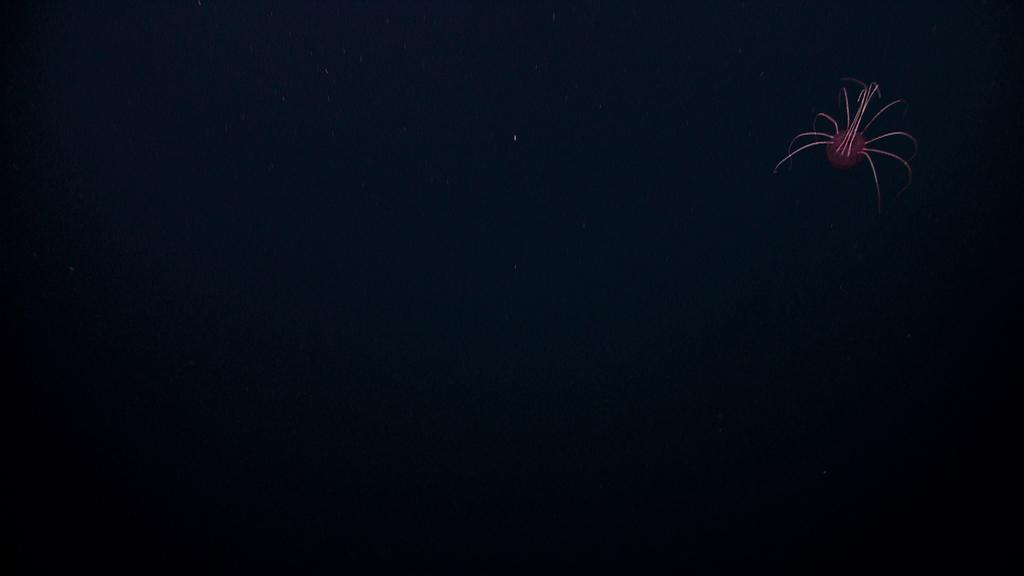What is located on the right side of the image? There is a light on the right side of the image. What color is the background of the image? The background of the image is black. What type of sidewalk can be seen in the image? There is no sidewalk present in the image. Where is the hydrant located in the image? There is no hydrant present in the image. What tool is being used to cut something in the image? There are no scissors or any cutting tools present in the image. 